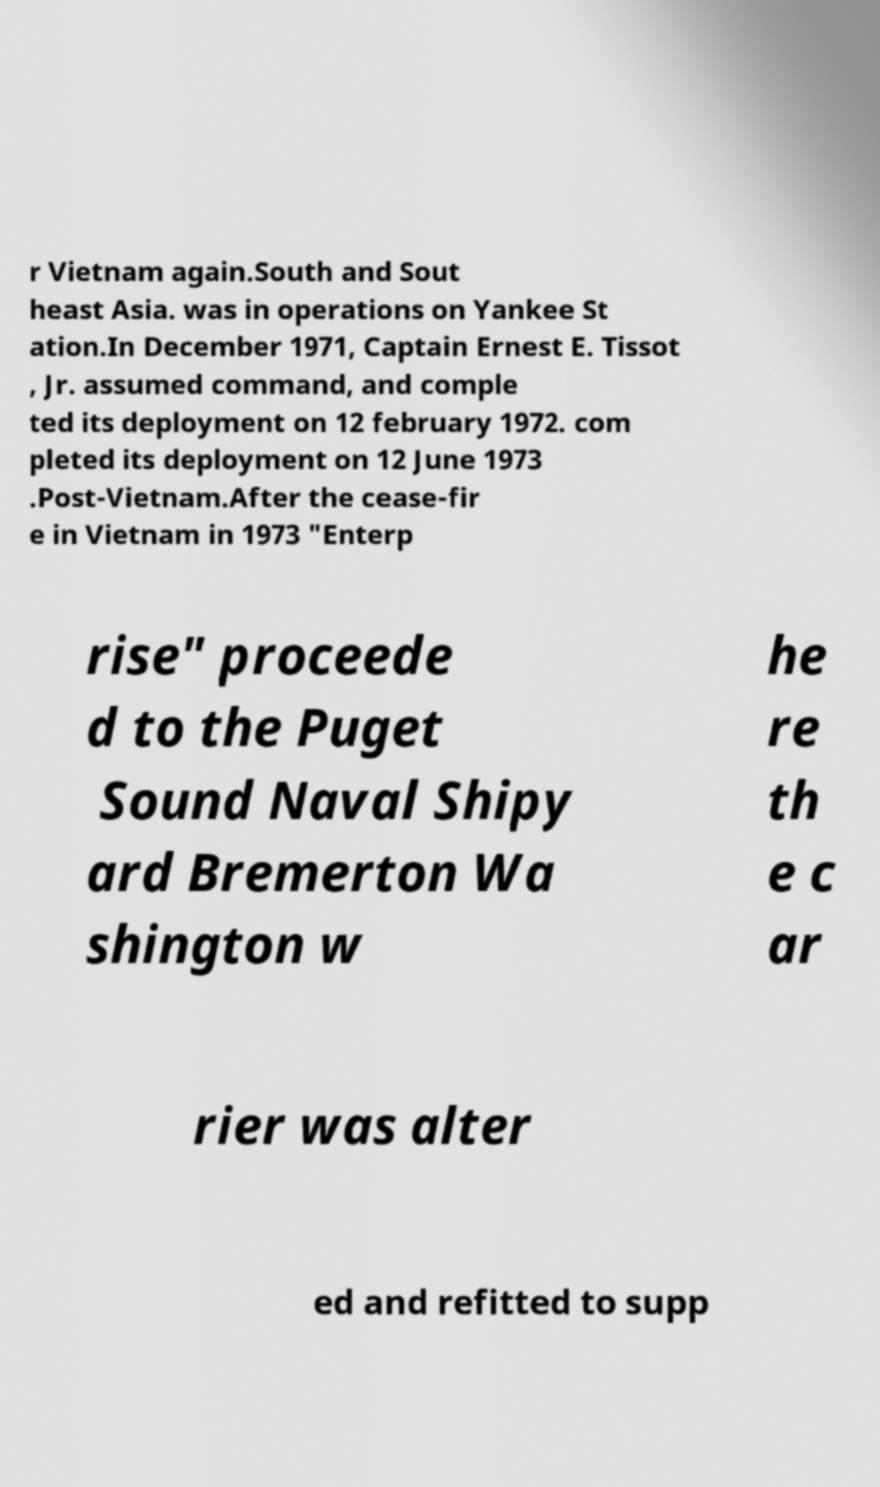Could you extract and type out the text from this image? r Vietnam again.South and Sout heast Asia. was in operations on Yankee St ation.In December 1971, Captain Ernest E. Tissot , Jr. assumed command, and comple ted its deployment on 12 february 1972. com pleted its deployment on 12 June 1973 .Post-Vietnam.After the cease-fir e in Vietnam in 1973 "Enterp rise" proceede d to the Puget Sound Naval Shipy ard Bremerton Wa shington w he re th e c ar rier was alter ed and refitted to supp 